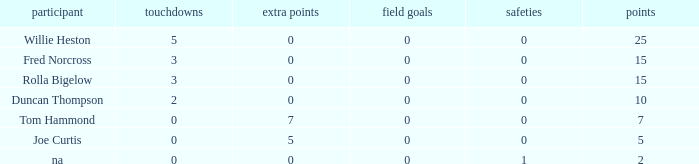How many Touchdowns have a Player of rolla bigelow, and an Extra points smaller than 0? None. 